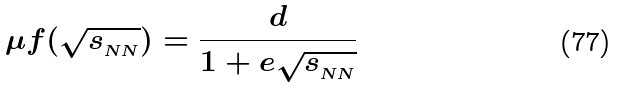Convert formula to latex. <formula><loc_0><loc_0><loc_500><loc_500>\mu f ( \sqrt { s _ { _ { N N } } } ) = \frac { d } { 1 + e \sqrt { s _ { _ { N N } } } }</formula> 